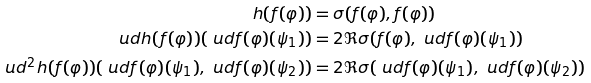Convert formula to latex. <formula><loc_0><loc_0><loc_500><loc_500>h ( f ( \varphi ) ) & = \sigma ( f ( \varphi ) , f ( \varphi ) ) \\ \ u d h ( f ( \varphi ) ) ( \ u d f ( \varphi ) ( \psi _ { 1 } ) ) & = 2 \Re \sigma ( f ( \varphi ) , \ u d f ( \varphi ) ( \psi _ { 1 } ) ) \\ \ u d ^ { 2 } h ( f ( \varphi ) ) ( \ u d f ( \varphi ) ( \psi _ { 1 } ) , \ u d f ( \varphi ) ( \psi _ { 2 } ) ) & = 2 \Re \sigma ( \ u d f ( \varphi ) ( \psi _ { 1 } ) , \ u d f ( \varphi ) ( \psi _ { 2 } ) )</formula> 